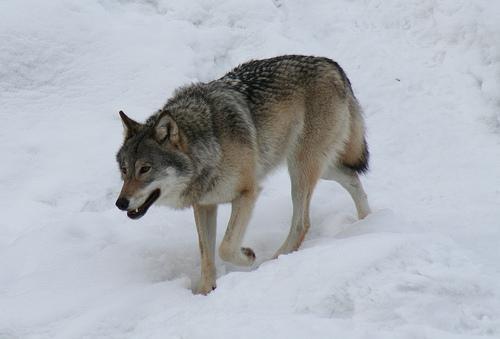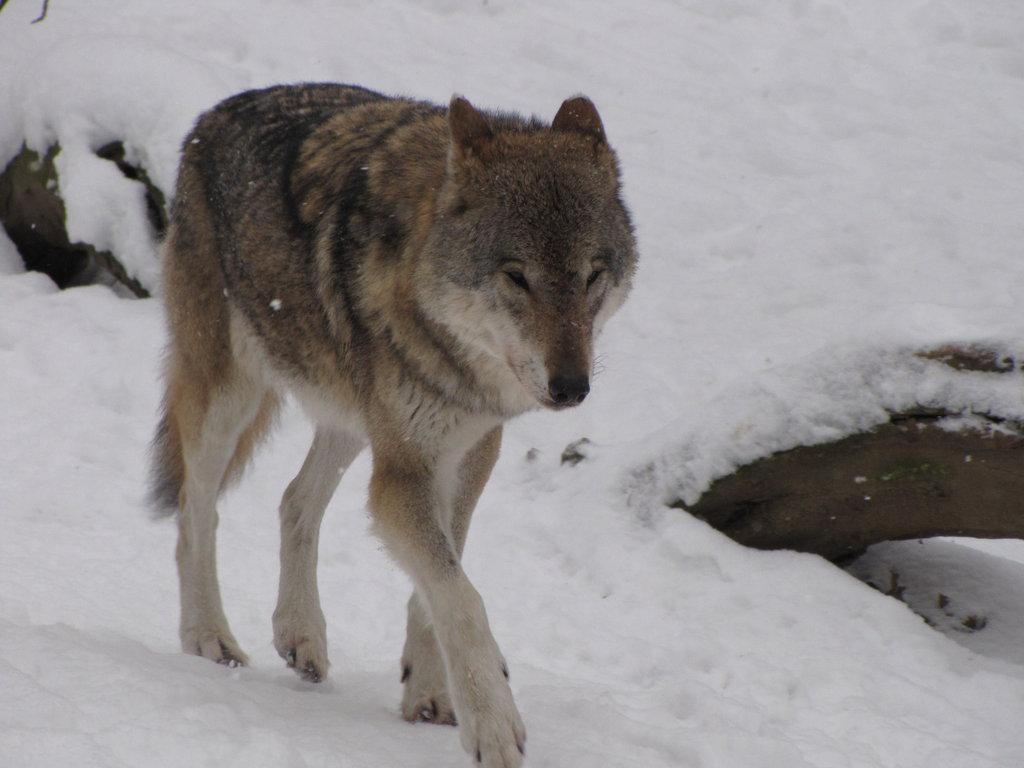The first image is the image on the left, the second image is the image on the right. Assess this claim about the two images: "The animal in the image on the left is moving left.". Correct or not? Answer yes or no. Yes. 